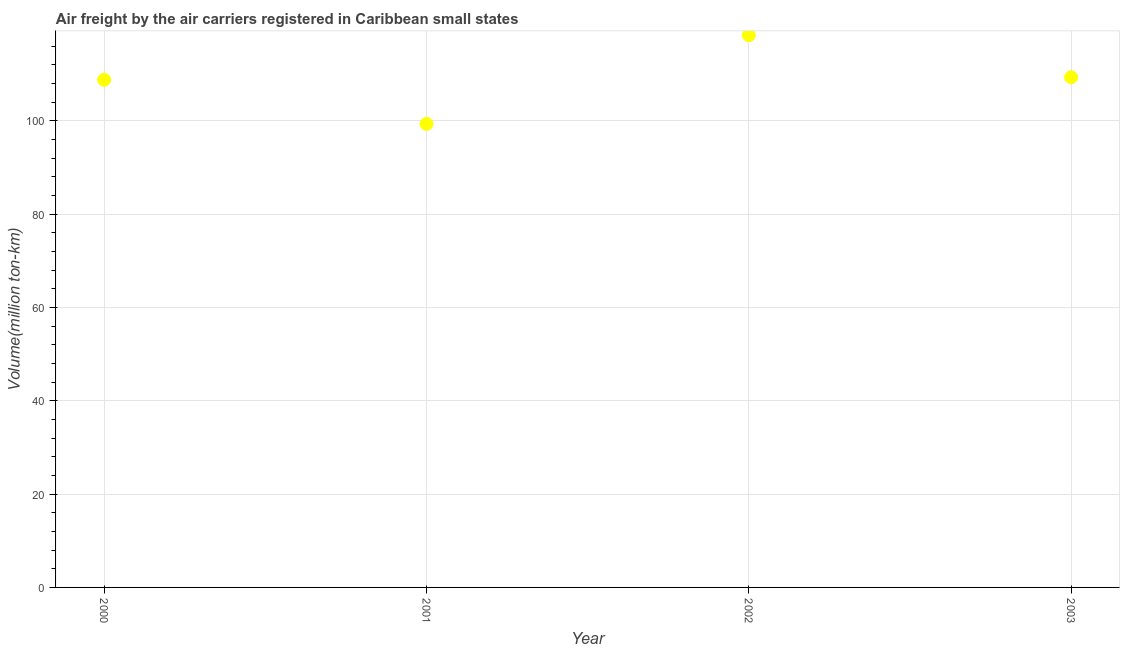What is the air freight in 2002?
Keep it short and to the point. 118.33. Across all years, what is the maximum air freight?
Provide a short and direct response. 118.33. Across all years, what is the minimum air freight?
Provide a short and direct response. 99.33. In which year was the air freight minimum?
Your answer should be very brief. 2001. What is the sum of the air freight?
Give a very brief answer. 435.79. What is the difference between the air freight in 2000 and 2003?
Ensure brevity in your answer.  -0.53. What is the average air freight per year?
Make the answer very short. 108.95. What is the median air freight?
Your answer should be compact. 109.06. In how many years, is the air freight greater than 24 million ton-km?
Your response must be concise. 4. Do a majority of the years between 2003 and 2002 (inclusive) have air freight greater than 108 million ton-km?
Make the answer very short. No. What is the ratio of the air freight in 2001 to that in 2003?
Provide a succinct answer. 0.91. Is the air freight in 2001 less than that in 2003?
Your answer should be very brief. Yes. Is the difference between the air freight in 2001 and 2002 greater than the difference between any two years?
Give a very brief answer. Yes. What is the difference between the highest and the second highest air freight?
Your answer should be compact. 9. What is the difference between the highest and the lowest air freight?
Your answer should be very brief. 19. In how many years, is the air freight greater than the average air freight taken over all years?
Provide a short and direct response. 2. What is the difference between two consecutive major ticks on the Y-axis?
Make the answer very short. 20. Does the graph contain any zero values?
Provide a succinct answer. No. What is the title of the graph?
Ensure brevity in your answer.  Air freight by the air carriers registered in Caribbean small states. What is the label or title of the X-axis?
Your answer should be very brief. Year. What is the label or title of the Y-axis?
Give a very brief answer. Volume(million ton-km). What is the Volume(million ton-km) in 2000?
Provide a short and direct response. 108.8. What is the Volume(million ton-km) in 2001?
Your answer should be compact. 99.33. What is the Volume(million ton-km) in 2002?
Give a very brief answer. 118.33. What is the Volume(million ton-km) in 2003?
Your response must be concise. 109.33. What is the difference between the Volume(million ton-km) in 2000 and 2001?
Give a very brief answer. 9.47. What is the difference between the Volume(million ton-km) in 2000 and 2002?
Give a very brief answer. -9.54. What is the difference between the Volume(million ton-km) in 2000 and 2003?
Your response must be concise. -0.53. What is the difference between the Volume(million ton-km) in 2001 and 2002?
Provide a succinct answer. -19. What is the difference between the Volume(million ton-km) in 2001 and 2003?
Your answer should be very brief. -10. What is the difference between the Volume(million ton-km) in 2002 and 2003?
Keep it short and to the point. 9. What is the ratio of the Volume(million ton-km) in 2000 to that in 2001?
Offer a terse response. 1.09. What is the ratio of the Volume(million ton-km) in 2000 to that in 2002?
Keep it short and to the point. 0.92. What is the ratio of the Volume(million ton-km) in 2001 to that in 2002?
Give a very brief answer. 0.84. What is the ratio of the Volume(million ton-km) in 2001 to that in 2003?
Ensure brevity in your answer.  0.91. What is the ratio of the Volume(million ton-km) in 2002 to that in 2003?
Your response must be concise. 1.08. 